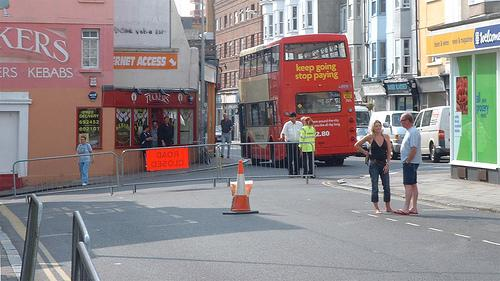Where are these 2 people standing?

Choices:
A) grass
B) street
C) trail
D) beach street 